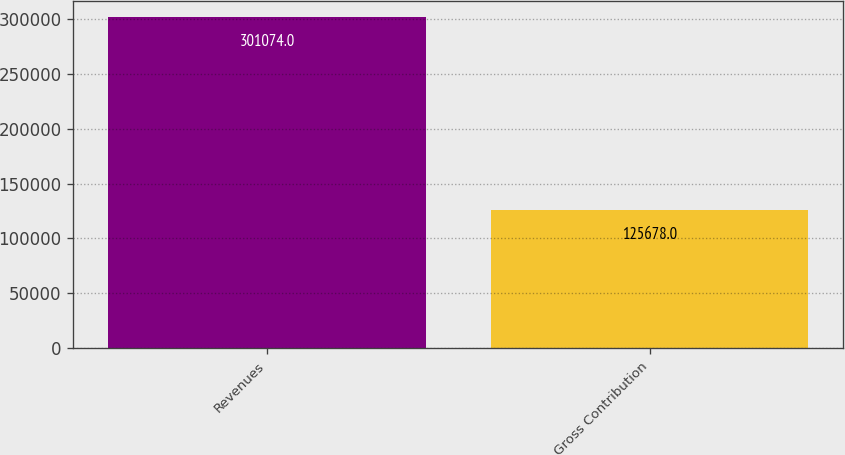Convert chart to OTSL. <chart><loc_0><loc_0><loc_500><loc_500><bar_chart><fcel>Revenues<fcel>Gross Contribution<nl><fcel>301074<fcel>125678<nl></chart> 